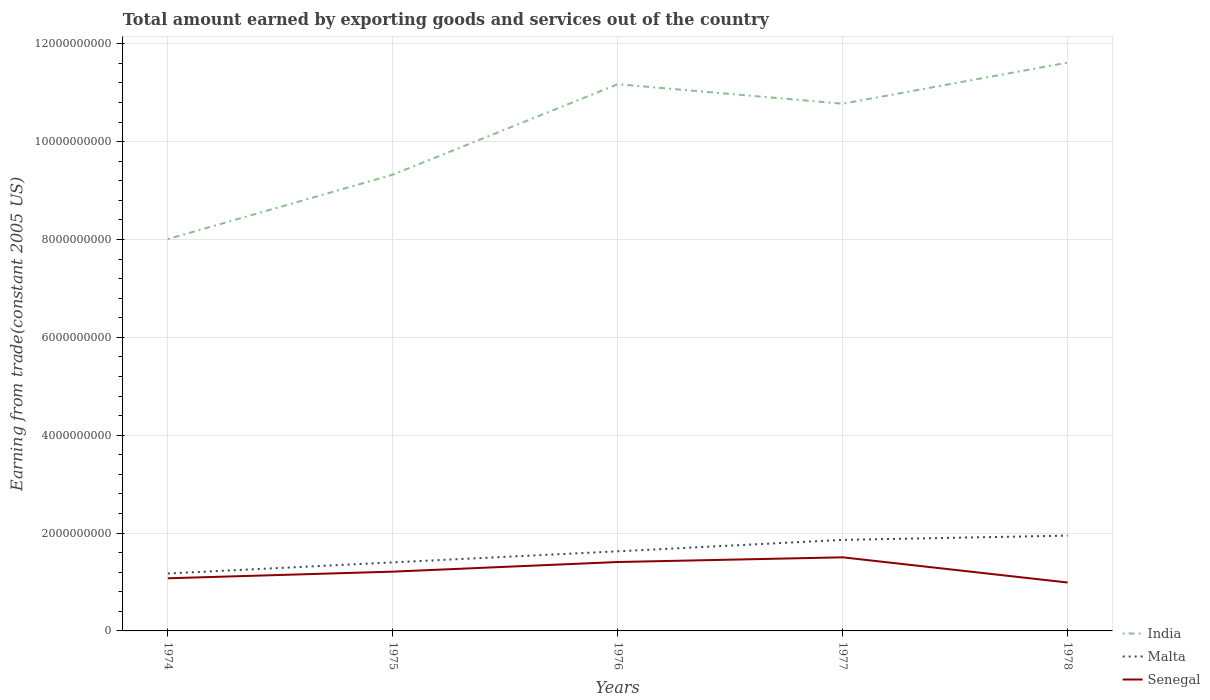Does the line corresponding to Malta intersect with the line corresponding to Senegal?
Provide a succinct answer. No. Is the number of lines equal to the number of legend labels?
Keep it short and to the point. Yes. Across all years, what is the maximum total amount earned by exporting goods and services in Malta?
Your response must be concise. 1.17e+09. In which year was the total amount earned by exporting goods and services in Senegal maximum?
Make the answer very short. 1978. What is the total total amount earned by exporting goods and services in India in the graph?
Your answer should be compact. -3.61e+09. What is the difference between the highest and the second highest total amount earned by exporting goods and services in India?
Your answer should be compact. 3.61e+09. Is the total amount earned by exporting goods and services in Malta strictly greater than the total amount earned by exporting goods and services in India over the years?
Offer a terse response. Yes. How many lines are there?
Provide a short and direct response. 3. How many years are there in the graph?
Offer a very short reply. 5. Does the graph contain grids?
Provide a succinct answer. Yes. How are the legend labels stacked?
Make the answer very short. Vertical. What is the title of the graph?
Your answer should be very brief. Total amount earned by exporting goods and services out of the country. Does "North America" appear as one of the legend labels in the graph?
Provide a short and direct response. No. What is the label or title of the Y-axis?
Your answer should be very brief. Earning from trade(constant 2005 US). What is the Earning from trade(constant 2005 US) in India in 1974?
Make the answer very short. 8.01e+09. What is the Earning from trade(constant 2005 US) of Malta in 1974?
Make the answer very short. 1.17e+09. What is the Earning from trade(constant 2005 US) of Senegal in 1974?
Your response must be concise. 1.08e+09. What is the Earning from trade(constant 2005 US) in India in 1975?
Provide a succinct answer. 9.33e+09. What is the Earning from trade(constant 2005 US) of Malta in 1975?
Keep it short and to the point. 1.40e+09. What is the Earning from trade(constant 2005 US) of Senegal in 1975?
Your response must be concise. 1.21e+09. What is the Earning from trade(constant 2005 US) of India in 1976?
Make the answer very short. 1.12e+1. What is the Earning from trade(constant 2005 US) in Malta in 1976?
Offer a terse response. 1.63e+09. What is the Earning from trade(constant 2005 US) of Senegal in 1976?
Give a very brief answer. 1.41e+09. What is the Earning from trade(constant 2005 US) of India in 1977?
Provide a short and direct response. 1.08e+1. What is the Earning from trade(constant 2005 US) in Malta in 1977?
Your answer should be very brief. 1.86e+09. What is the Earning from trade(constant 2005 US) in Senegal in 1977?
Provide a short and direct response. 1.50e+09. What is the Earning from trade(constant 2005 US) of India in 1978?
Make the answer very short. 1.16e+1. What is the Earning from trade(constant 2005 US) of Malta in 1978?
Your answer should be very brief. 1.95e+09. What is the Earning from trade(constant 2005 US) of Senegal in 1978?
Provide a succinct answer. 9.89e+08. Across all years, what is the maximum Earning from trade(constant 2005 US) in India?
Ensure brevity in your answer.  1.16e+1. Across all years, what is the maximum Earning from trade(constant 2005 US) in Malta?
Ensure brevity in your answer.  1.95e+09. Across all years, what is the maximum Earning from trade(constant 2005 US) of Senegal?
Offer a very short reply. 1.50e+09. Across all years, what is the minimum Earning from trade(constant 2005 US) in India?
Provide a short and direct response. 8.01e+09. Across all years, what is the minimum Earning from trade(constant 2005 US) in Malta?
Give a very brief answer. 1.17e+09. Across all years, what is the minimum Earning from trade(constant 2005 US) in Senegal?
Offer a terse response. 9.89e+08. What is the total Earning from trade(constant 2005 US) of India in the graph?
Your answer should be very brief. 5.09e+1. What is the total Earning from trade(constant 2005 US) of Malta in the graph?
Ensure brevity in your answer.  8.01e+09. What is the total Earning from trade(constant 2005 US) of Senegal in the graph?
Your answer should be compact. 6.19e+09. What is the difference between the Earning from trade(constant 2005 US) in India in 1974 and that in 1975?
Provide a short and direct response. -1.32e+09. What is the difference between the Earning from trade(constant 2005 US) in Malta in 1974 and that in 1975?
Offer a terse response. -2.28e+08. What is the difference between the Earning from trade(constant 2005 US) of Senegal in 1974 and that in 1975?
Ensure brevity in your answer.  -1.36e+08. What is the difference between the Earning from trade(constant 2005 US) of India in 1974 and that in 1976?
Your answer should be very brief. -3.17e+09. What is the difference between the Earning from trade(constant 2005 US) in Malta in 1974 and that in 1976?
Provide a short and direct response. -4.54e+08. What is the difference between the Earning from trade(constant 2005 US) of Senegal in 1974 and that in 1976?
Offer a very short reply. -3.33e+08. What is the difference between the Earning from trade(constant 2005 US) in India in 1974 and that in 1977?
Provide a short and direct response. -2.77e+09. What is the difference between the Earning from trade(constant 2005 US) in Malta in 1974 and that in 1977?
Give a very brief answer. -6.87e+08. What is the difference between the Earning from trade(constant 2005 US) in Senegal in 1974 and that in 1977?
Keep it short and to the point. -4.28e+08. What is the difference between the Earning from trade(constant 2005 US) of India in 1974 and that in 1978?
Provide a succinct answer. -3.61e+09. What is the difference between the Earning from trade(constant 2005 US) in Malta in 1974 and that in 1978?
Give a very brief answer. -7.75e+08. What is the difference between the Earning from trade(constant 2005 US) in Senegal in 1974 and that in 1978?
Ensure brevity in your answer.  8.65e+07. What is the difference between the Earning from trade(constant 2005 US) in India in 1975 and that in 1976?
Your answer should be very brief. -1.85e+09. What is the difference between the Earning from trade(constant 2005 US) in Malta in 1975 and that in 1976?
Ensure brevity in your answer.  -2.26e+08. What is the difference between the Earning from trade(constant 2005 US) of Senegal in 1975 and that in 1976?
Keep it short and to the point. -1.97e+08. What is the difference between the Earning from trade(constant 2005 US) of India in 1975 and that in 1977?
Make the answer very short. -1.45e+09. What is the difference between the Earning from trade(constant 2005 US) of Malta in 1975 and that in 1977?
Your response must be concise. -4.59e+08. What is the difference between the Earning from trade(constant 2005 US) of Senegal in 1975 and that in 1977?
Keep it short and to the point. -2.93e+08. What is the difference between the Earning from trade(constant 2005 US) of India in 1975 and that in 1978?
Offer a very short reply. -2.29e+09. What is the difference between the Earning from trade(constant 2005 US) in Malta in 1975 and that in 1978?
Offer a terse response. -5.47e+08. What is the difference between the Earning from trade(constant 2005 US) in Senegal in 1975 and that in 1978?
Offer a very short reply. 2.22e+08. What is the difference between the Earning from trade(constant 2005 US) of India in 1976 and that in 1977?
Your answer should be very brief. 3.99e+08. What is the difference between the Earning from trade(constant 2005 US) of Malta in 1976 and that in 1977?
Make the answer very short. -2.34e+08. What is the difference between the Earning from trade(constant 2005 US) in Senegal in 1976 and that in 1977?
Offer a terse response. -9.58e+07. What is the difference between the Earning from trade(constant 2005 US) of India in 1976 and that in 1978?
Keep it short and to the point. -4.42e+08. What is the difference between the Earning from trade(constant 2005 US) of Malta in 1976 and that in 1978?
Provide a short and direct response. -3.21e+08. What is the difference between the Earning from trade(constant 2005 US) in Senegal in 1976 and that in 1978?
Make the answer very short. 4.19e+08. What is the difference between the Earning from trade(constant 2005 US) of India in 1977 and that in 1978?
Your answer should be compact. -8.41e+08. What is the difference between the Earning from trade(constant 2005 US) of Malta in 1977 and that in 1978?
Your answer should be very brief. -8.76e+07. What is the difference between the Earning from trade(constant 2005 US) in Senegal in 1977 and that in 1978?
Make the answer very short. 5.15e+08. What is the difference between the Earning from trade(constant 2005 US) of India in 1974 and the Earning from trade(constant 2005 US) of Malta in 1975?
Offer a terse response. 6.61e+09. What is the difference between the Earning from trade(constant 2005 US) in India in 1974 and the Earning from trade(constant 2005 US) in Senegal in 1975?
Ensure brevity in your answer.  6.80e+09. What is the difference between the Earning from trade(constant 2005 US) of Malta in 1974 and the Earning from trade(constant 2005 US) of Senegal in 1975?
Your response must be concise. -3.81e+07. What is the difference between the Earning from trade(constant 2005 US) in India in 1974 and the Earning from trade(constant 2005 US) in Malta in 1976?
Provide a short and direct response. 6.38e+09. What is the difference between the Earning from trade(constant 2005 US) in India in 1974 and the Earning from trade(constant 2005 US) in Senegal in 1976?
Offer a terse response. 6.60e+09. What is the difference between the Earning from trade(constant 2005 US) in Malta in 1974 and the Earning from trade(constant 2005 US) in Senegal in 1976?
Keep it short and to the point. -2.35e+08. What is the difference between the Earning from trade(constant 2005 US) of India in 1974 and the Earning from trade(constant 2005 US) of Malta in 1977?
Your answer should be very brief. 6.15e+09. What is the difference between the Earning from trade(constant 2005 US) in India in 1974 and the Earning from trade(constant 2005 US) in Senegal in 1977?
Offer a terse response. 6.50e+09. What is the difference between the Earning from trade(constant 2005 US) in Malta in 1974 and the Earning from trade(constant 2005 US) in Senegal in 1977?
Offer a very short reply. -3.31e+08. What is the difference between the Earning from trade(constant 2005 US) of India in 1974 and the Earning from trade(constant 2005 US) of Malta in 1978?
Provide a succinct answer. 6.06e+09. What is the difference between the Earning from trade(constant 2005 US) of India in 1974 and the Earning from trade(constant 2005 US) of Senegal in 1978?
Provide a short and direct response. 7.02e+09. What is the difference between the Earning from trade(constant 2005 US) of Malta in 1974 and the Earning from trade(constant 2005 US) of Senegal in 1978?
Offer a terse response. 1.84e+08. What is the difference between the Earning from trade(constant 2005 US) in India in 1975 and the Earning from trade(constant 2005 US) in Malta in 1976?
Give a very brief answer. 7.70e+09. What is the difference between the Earning from trade(constant 2005 US) of India in 1975 and the Earning from trade(constant 2005 US) of Senegal in 1976?
Offer a terse response. 7.92e+09. What is the difference between the Earning from trade(constant 2005 US) in Malta in 1975 and the Earning from trade(constant 2005 US) in Senegal in 1976?
Provide a short and direct response. -7.07e+06. What is the difference between the Earning from trade(constant 2005 US) of India in 1975 and the Earning from trade(constant 2005 US) of Malta in 1977?
Offer a terse response. 7.47e+09. What is the difference between the Earning from trade(constant 2005 US) of India in 1975 and the Earning from trade(constant 2005 US) of Senegal in 1977?
Your response must be concise. 7.82e+09. What is the difference between the Earning from trade(constant 2005 US) of Malta in 1975 and the Earning from trade(constant 2005 US) of Senegal in 1977?
Your answer should be compact. -1.03e+08. What is the difference between the Earning from trade(constant 2005 US) in India in 1975 and the Earning from trade(constant 2005 US) in Malta in 1978?
Keep it short and to the point. 7.38e+09. What is the difference between the Earning from trade(constant 2005 US) of India in 1975 and the Earning from trade(constant 2005 US) of Senegal in 1978?
Offer a terse response. 8.34e+09. What is the difference between the Earning from trade(constant 2005 US) in Malta in 1975 and the Earning from trade(constant 2005 US) in Senegal in 1978?
Your answer should be very brief. 4.12e+08. What is the difference between the Earning from trade(constant 2005 US) in India in 1976 and the Earning from trade(constant 2005 US) in Malta in 1977?
Your answer should be compact. 9.31e+09. What is the difference between the Earning from trade(constant 2005 US) in India in 1976 and the Earning from trade(constant 2005 US) in Senegal in 1977?
Offer a terse response. 9.67e+09. What is the difference between the Earning from trade(constant 2005 US) in Malta in 1976 and the Earning from trade(constant 2005 US) in Senegal in 1977?
Provide a succinct answer. 1.23e+08. What is the difference between the Earning from trade(constant 2005 US) of India in 1976 and the Earning from trade(constant 2005 US) of Malta in 1978?
Make the answer very short. 9.23e+09. What is the difference between the Earning from trade(constant 2005 US) in India in 1976 and the Earning from trade(constant 2005 US) in Senegal in 1978?
Keep it short and to the point. 1.02e+1. What is the difference between the Earning from trade(constant 2005 US) in Malta in 1976 and the Earning from trade(constant 2005 US) in Senegal in 1978?
Your answer should be compact. 6.38e+08. What is the difference between the Earning from trade(constant 2005 US) in India in 1977 and the Earning from trade(constant 2005 US) in Malta in 1978?
Your answer should be compact. 8.83e+09. What is the difference between the Earning from trade(constant 2005 US) of India in 1977 and the Earning from trade(constant 2005 US) of Senegal in 1978?
Your answer should be very brief. 9.79e+09. What is the difference between the Earning from trade(constant 2005 US) of Malta in 1977 and the Earning from trade(constant 2005 US) of Senegal in 1978?
Keep it short and to the point. 8.71e+08. What is the average Earning from trade(constant 2005 US) of India per year?
Your response must be concise. 1.02e+1. What is the average Earning from trade(constant 2005 US) in Malta per year?
Offer a very short reply. 1.60e+09. What is the average Earning from trade(constant 2005 US) in Senegal per year?
Offer a very short reply. 1.24e+09. In the year 1974, what is the difference between the Earning from trade(constant 2005 US) of India and Earning from trade(constant 2005 US) of Malta?
Offer a very short reply. 6.84e+09. In the year 1974, what is the difference between the Earning from trade(constant 2005 US) in India and Earning from trade(constant 2005 US) in Senegal?
Offer a very short reply. 6.93e+09. In the year 1974, what is the difference between the Earning from trade(constant 2005 US) in Malta and Earning from trade(constant 2005 US) in Senegal?
Provide a succinct answer. 9.77e+07. In the year 1975, what is the difference between the Earning from trade(constant 2005 US) in India and Earning from trade(constant 2005 US) in Malta?
Your answer should be compact. 7.92e+09. In the year 1975, what is the difference between the Earning from trade(constant 2005 US) of India and Earning from trade(constant 2005 US) of Senegal?
Provide a succinct answer. 8.11e+09. In the year 1975, what is the difference between the Earning from trade(constant 2005 US) of Malta and Earning from trade(constant 2005 US) of Senegal?
Provide a short and direct response. 1.90e+08. In the year 1976, what is the difference between the Earning from trade(constant 2005 US) of India and Earning from trade(constant 2005 US) of Malta?
Your answer should be compact. 9.55e+09. In the year 1976, what is the difference between the Earning from trade(constant 2005 US) of India and Earning from trade(constant 2005 US) of Senegal?
Keep it short and to the point. 9.77e+09. In the year 1976, what is the difference between the Earning from trade(constant 2005 US) in Malta and Earning from trade(constant 2005 US) in Senegal?
Your answer should be very brief. 2.19e+08. In the year 1977, what is the difference between the Earning from trade(constant 2005 US) of India and Earning from trade(constant 2005 US) of Malta?
Offer a terse response. 8.92e+09. In the year 1977, what is the difference between the Earning from trade(constant 2005 US) of India and Earning from trade(constant 2005 US) of Senegal?
Provide a succinct answer. 9.27e+09. In the year 1977, what is the difference between the Earning from trade(constant 2005 US) in Malta and Earning from trade(constant 2005 US) in Senegal?
Offer a terse response. 3.56e+08. In the year 1978, what is the difference between the Earning from trade(constant 2005 US) of India and Earning from trade(constant 2005 US) of Malta?
Your response must be concise. 9.67e+09. In the year 1978, what is the difference between the Earning from trade(constant 2005 US) in India and Earning from trade(constant 2005 US) in Senegal?
Offer a very short reply. 1.06e+1. In the year 1978, what is the difference between the Earning from trade(constant 2005 US) of Malta and Earning from trade(constant 2005 US) of Senegal?
Ensure brevity in your answer.  9.59e+08. What is the ratio of the Earning from trade(constant 2005 US) in India in 1974 to that in 1975?
Your answer should be very brief. 0.86. What is the ratio of the Earning from trade(constant 2005 US) in Malta in 1974 to that in 1975?
Your answer should be very brief. 0.84. What is the ratio of the Earning from trade(constant 2005 US) of Senegal in 1974 to that in 1975?
Your response must be concise. 0.89. What is the ratio of the Earning from trade(constant 2005 US) of India in 1974 to that in 1976?
Offer a terse response. 0.72. What is the ratio of the Earning from trade(constant 2005 US) in Malta in 1974 to that in 1976?
Provide a short and direct response. 0.72. What is the ratio of the Earning from trade(constant 2005 US) of Senegal in 1974 to that in 1976?
Your answer should be very brief. 0.76. What is the ratio of the Earning from trade(constant 2005 US) in India in 1974 to that in 1977?
Make the answer very short. 0.74. What is the ratio of the Earning from trade(constant 2005 US) of Malta in 1974 to that in 1977?
Your response must be concise. 0.63. What is the ratio of the Earning from trade(constant 2005 US) of Senegal in 1974 to that in 1977?
Your answer should be very brief. 0.72. What is the ratio of the Earning from trade(constant 2005 US) of India in 1974 to that in 1978?
Keep it short and to the point. 0.69. What is the ratio of the Earning from trade(constant 2005 US) in Malta in 1974 to that in 1978?
Offer a very short reply. 0.6. What is the ratio of the Earning from trade(constant 2005 US) of Senegal in 1974 to that in 1978?
Your answer should be very brief. 1.09. What is the ratio of the Earning from trade(constant 2005 US) in India in 1975 to that in 1976?
Offer a terse response. 0.83. What is the ratio of the Earning from trade(constant 2005 US) of Malta in 1975 to that in 1976?
Offer a terse response. 0.86. What is the ratio of the Earning from trade(constant 2005 US) in Senegal in 1975 to that in 1976?
Give a very brief answer. 0.86. What is the ratio of the Earning from trade(constant 2005 US) of India in 1975 to that in 1977?
Offer a very short reply. 0.87. What is the ratio of the Earning from trade(constant 2005 US) in Malta in 1975 to that in 1977?
Keep it short and to the point. 0.75. What is the ratio of the Earning from trade(constant 2005 US) of Senegal in 1975 to that in 1977?
Your answer should be compact. 0.81. What is the ratio of the Earning from trade(constant 2005 US) of India in 1975 to that in 1978?
Give a very brief answer. 0.8. What is the ratio of the Earning from trade(constant 2005 US) in Malta in 1975 to that in 1978?
Offer a very short reply. 0.72. What is the ratio of the Earning from trade(constant 2005 US) of Senegal in 1975 to that in 1978?
Keep it short and to the point. 1.22. What is the ratio of the Earning from trade(constant 2005 US) of India in 1976 to that in 1977?
Your response must be concise. 1.04. What is the ratio of the Earning from trade(constant 2005 US) in Malta in 1976 to that in 1977?
Offer a terse response. 0.87. What is the ratio of the Earning from trade(constant 2005 US) of Senegal in 1976 to that in 1977?
Provide a succinct answer. 0.94. What is the ratio of the Earning from trade(constant 2005 US) of India in 1976 to that in 1978?
Keep it short and to the point. 0.96. What is the ratio of the Earning from trade(constant 2005 US) in Malta in 1976 to that in 1978?
Offer a very short reply. 0.84. What is the ratio of the Earning from trade(constant 2005 US) of Senegal in 1976 to that in 1978?
Your response must be concise. 1.42. What is the ratio of the Earning from trade(constant 2005 US) of India in 1977 to that in 1978?
Your answer should be very brief. 0.93. What is the ratio of the Earning from trade(constant 2005 US) of Malta in 1977 to that in 1978?
Your response must be concise. 0.95. What is the ratio of the Earning from trade(constant 2005 US) of Senegal in 1977 to that in 1978?
Make the answer very short. 1.52. What is the difference between the highest and the second highest Earning from trade(constant 2005 US) in India?
Keep it short and to the point. 4.42e+08. What is the difference between the highest and the second highest Earning from trade(constant 2005 US) of Malta?
Make the answer very short. 8.76e+07. What is the difference between the highest and the second highest Earning from trade(constant 2005 US) in Senegal?
Keep it short and to the point. 9.58e+07. What is the difference between the highest and the lowest Earning from trade(constant 2005 US) in India?
Make the answer very short. 3.61e+09. What is the difference between the highest and the lowest Earning from trade(constant 2005 US) in Malta?
Keep it short and to the point. 7.75e+08. What is the difference between the highest and the lowest Earning from trade(constant 2005 US) in Senegal?
Offer a very short reply. 5.15e+08. 